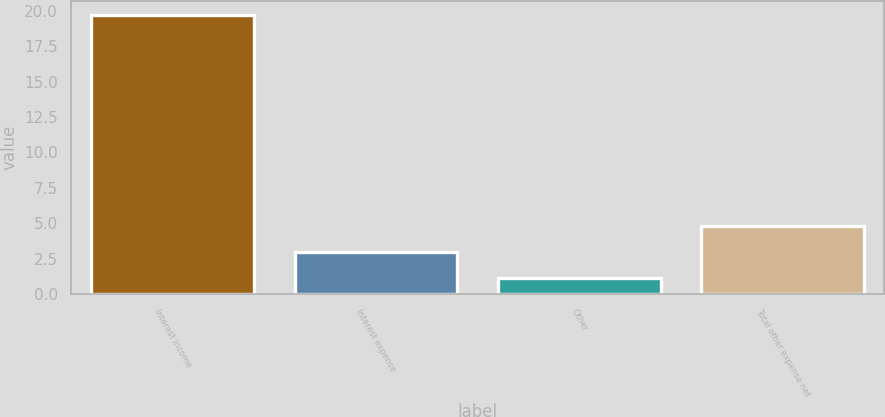Convert chart to OTSL. <chart><loc_0><loc_0><loc_500><loc_500><bar_chart><fcel>Interest income<fcel>Interest expense<fcel>Other<fcel>Total other expense net<nl><fcel>19.7<fcel>2.96<fcel>1.1<fcel>4.82<nl></chart> 